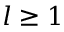Convert formula to latex. <formula><loc_0><loc_0><loc_500><loc_500>l \geq 1</formula> 